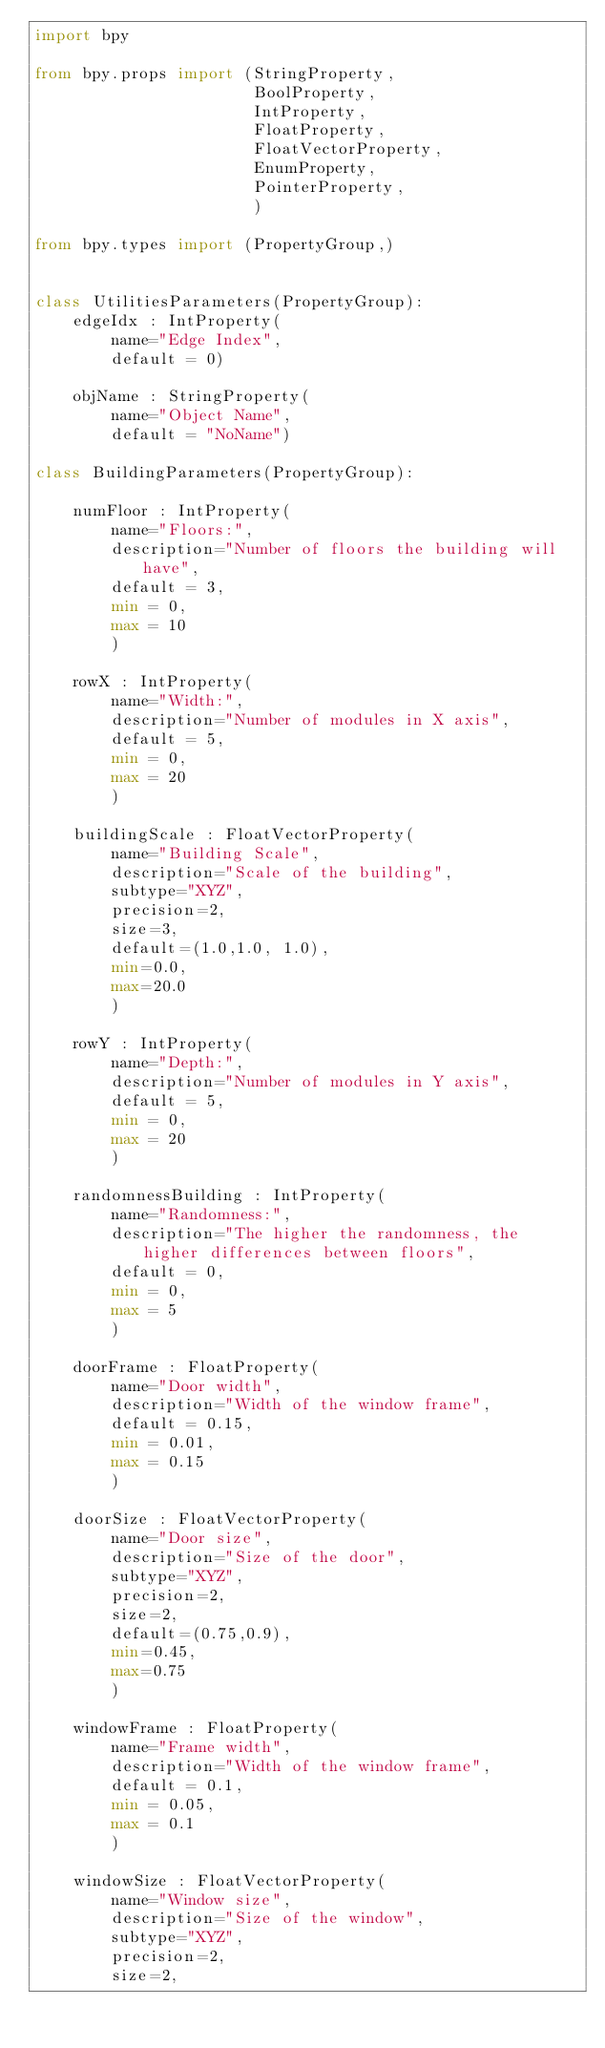Convert code to text. <code><loc_0><loc_0><loc_500><loc_500><_Python_>import bpy

from bpy.props import (StringProperty,
                       BoolProperty,
                       IntProperty,
                       FloatProperty,
                       FloatVectorProperty,
                       EnumProperty,
                       PointerProperty,
                       )
                       
from bpy.types import (PropertyGroup,)
                       

class UtilitiesParameters(PropertyGroup):
    edgeIdx : IntProperty(
        name="Edge Index",
        default = 0)
        
    objName : StringProperty(
        name="Object Name",
        default = "NoName")

class BuildingParameters(PropertyGroup):     
                     
    numFloor : IntProperty(
        name="Floors:",
        description="Number of floors the building will have",
        default = 3,
        min = 0,
        max = 10
        )
    
    rowX : IntProperty(
        name="Width:",
        description="Number of modules in X axis",
        default = 5,
        min = 0,
        max = 20
        )
        
    buildingScale : FloatVectorProperty(
        name="Building Scale",
        description="Scale of the building",
        subtype="XYZ",
        precision=2,
        size=3,
        default=(1.0,1.0, 1.0),
        min=0.0,
        max=20.0
        )
        
    rowY : IntProperty(
        name="Depth:",
        description="Number of modules in Y axis",
        default = 5,
        min = 0,
        max = 20
        )
        
    randomnessBuilding : IntProperty(
        name="Randomness:",
        description="The higher the randomness, the higher differences between floors",
        default = 0,
        min = 0,
        max = 5
        )
    
    doorFrame : FloatProperty(
        name="Door width",
        description="Width of the window frame",
        default = 0.15,
        min = 0.01,
        max = 0.15
        )
    
    doorSize : FloatVectorProperty(
        name="Door size",
        description="Size of the door",
        subtype="XYZ",
        precision=2,
        size=2,
        default=(0.75,0.9),
        min=0.45,
        max=0.75
        )
    
    windowFrame : FloatProperty(
        name="Frame width",
        description="Width of the window frame",
        default = 0.1,
        min = 0.05,
        max = 0.1
        )
        
    windowSize : FloatVectorProperty(
        name="Window size",
        description="Size of the window",
        subtype="XYZ",
        precision=2,
        size=2,</code> 